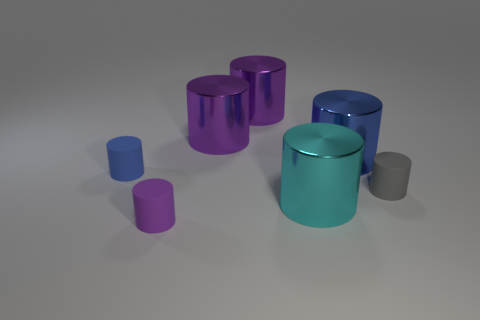Subtract all purple cylinders. How many were subtracted if there are1purple cylinders left? 2 Subtract all yellow blocks. How many purple cylinders are left? 3 Subtract 3 cylinders. How many cylinders are left? 4 Subtract all shiny cylinders. How many cylinders are left? 3 Subtract all gray cylinders. How many cylinders are left? 6 Add 3 small blue rubber things. How many objects exist? 10 Subtract all purple cylinders. Subtract all purple cubes. How many cylinders are left? 4 Add 1 big cyan objects. How many big cyan objects are left? 2 Add 7 big blue metallic things. How many big blue metallic things exist? 8 Subtract 0 blue balls. How many objects are left? 7 